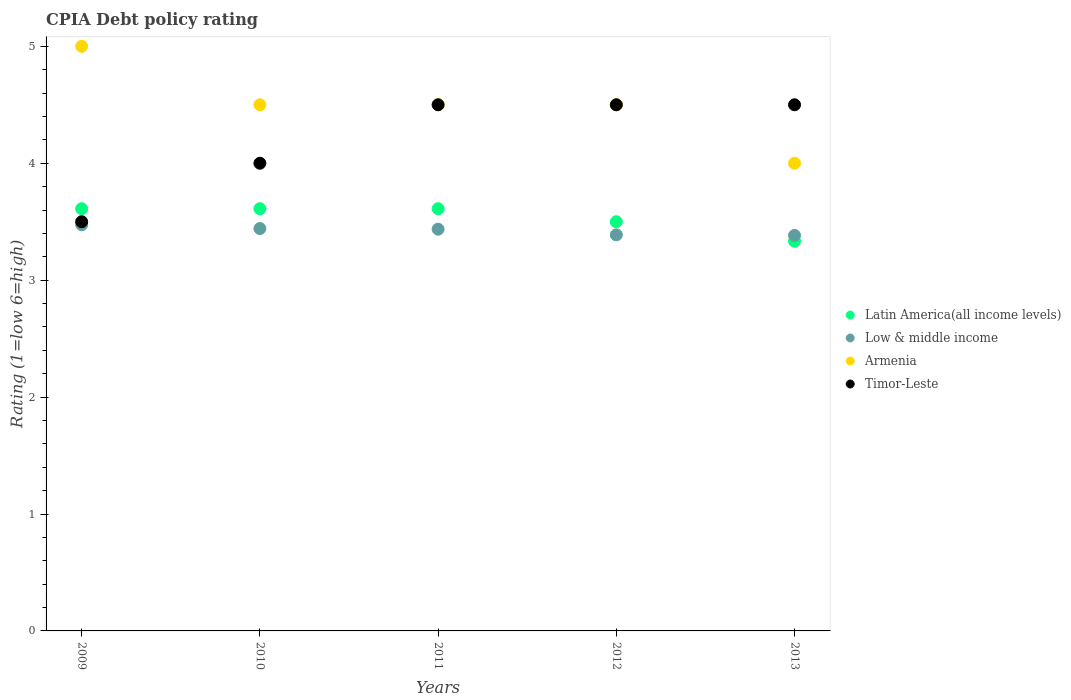How many different coloured dotlines are there?
Provide a short and direct response. 4. Across all years, what is the maximum CPIA rating in Low & middle income?
Give a very brief answer. 3.47. Across all years, what is the minimum CPIA rating in Low & middle income?
Your answer should be compact. 3.38. What is the total CPIA rating in Low & middle income in the graph?
Keep it short and to the point. 17.12. What is the difference between the CPIA rating in Low & middle income in 2009 and that in 2012?
Your response must be concise. 0.09. What is the difference between the CPIA rating in Latin America(all income levels) in 2013 and the CPIA rating in Low & middle income in 2009?
Your answer should be very brief. -0.14. In the year 2012, what is the difference between the CPIA rating in Latin America(all income levels) and CPIA rating in Armenia?
Provide a short and direct response. -1. What is the ratio of the CPIA rating in Latin America(all income levels) in 2011 to that in 2013?
Offer a very short reply. 1.08. What is the difference between the highest and the second highest CPIA rating in Low & middle income?
Give a very brief answer. 0.03. In how many years, is the CPIA rating in Armenia greater than the average CPIA rating in Armenia taken over all years?
Keep it short and to the point. 1. Is it the case that in every year, the sum of the CPIA rating in Low & middle income and CPIA rating in Timor-Leste  is greater than the sum of CPIA rating in Latin America(all income levels) and CPIA rating in Armenia?
Provide a short and direct response. No. Is the CPIA rating in Low & middle income strictly greater than the CPIA rating in Latin America(all income levels) over the years?
Provide a succinct answer. No. How many dotlines are there?
Offer a very short reply. 4. What is the difference between two consecutive major ticks on the Y-axis?
Ensure brevity in your answer.  1. Are the values on the major ticks of Y-axis written in scientific E-notation?
Provide a succinct answer. No. Does the graph contain grids?
Provide a short and direct response. No. What is the title of the graph?
Keep it short and to the point. CPIA Debt policy rating. Does "Croatia" appear as one of the legend labels in the graph?
Provide a succinct answer. No. What is the Rating (1=low 6=high) in Latin America(all income levels) in 2009?
Give a very brief answer. 3.61. What is the Rating (1=low 6=high) in Low & middle income in 2009?
Make the answer very short. 3.47. What is the Rating (1=low 6=high) of Timor-Leste in 2009?
Your answer should be very brief. 3.5. What is the Rating (1=low 6=high) in Latin America(all income levels) in 2010?
Offer a terse response. 3.61. What is the Rating (1=low 6=high) of Low & middle income in 2010?
Provide a succinct answer. 3.44. What is the Rating (1=low 6=high) of Armenia in 2010?
Offer a terse response. 4.5. What is the Rating (1=low 6=high) in Timor-Leste in 2010?
Your answer should be very brief. 4. What is the Rating (1=low 6=high) in Latin America(all income levels) in 2011?
Ensure brevity in your answer.  3.61. What is the Rating (1=low 6=high) in Low & middle income in 2011?
Keep it short and to the point. 3.44. What is the Rating (1=low 6=high) in Armenia in 2011?
Provide a succinct answer. 4.5. What is the Rating (1=low 6=high) of Timor-Leste in 2011?
Keep it short and to the point. 4.5. What is the Rating (1=low 6=high) of Low & middle income in 2012?
Offer a terse response. 3.39. What is the Rating (1=low 6=high) in Armenia in 2012?
Your answer should be very brief. 4.5. What is the Rating (1=low 6=high) of Latin America(all income levels) in 2013?
Your response must be concise. 3.33. What is the Rating (1=low 6=high) in Low & middle income in 2013?
Offer a very short reply. 3.38. What is the Rating (1=low 6=high) in Timor-Leste in 2013?
Make the answer very short. 4.5. Across all years, what is the maximum Rating (1=low 6=high) of Latin America(all income levels)?
Your answer should be very brief. 3.61. Across all years, what is the maximum Rating (1=low 6=high) in Low & middle income?
Give a very brief answer. 3.47. Across all years, what is the maximum Rating (1=low 6=high) in Armenia?
Provide a succinct answer. 5. Across all years, what is the minimum Rating (1=low 6=high) of Latin America(all income levels)?
Your answer should be very brief. 3.33. Across all years, what is the minimum Rating (1=low 6=high) of Low & middle income?
Offer a very short reply. 3.38. What is the total Rating (1=low 6=high) in Latin America(all income levels) in the graph?
Give a very brief answer. 17.67. What is the total Rating (1=low 6=high) of Low & middle income in the graph?
Your answer should be compact. 17.12. What is the total Rating (1=low 6=high) of Timor-Leste in the graph?
Your answer should be very brief. 21. What is the difference between the Rating (1=low 6=high) of Latin America(all income levels) in 2009 and that in 2010?
Your answer should be compact. 0. What is the difference between the Rating (1=low 6=high) in Low & middle income in 2009 and that in 2010?
Ensure brevity in your answer.  0.03. What is the difference between the Rating (1=low 6=high) in Armenia in 2009 and that in 2010?
Ensure brevity in your answer.  0.5. What is the difference between the Rating (1=low 6=high) of Low & middle income in 2009 and that in 2011?
Provide a succinct answer. 0.04. What is the difference between the Rating (1=low 6=high) of Armenia in 2009 and that in 2011?
Offer a terse response. 0.5. What is the difference between the Rating (1=low 6=high) in Timor-Leste in 2009 and that in 2011?
Keep it short and to the point. -1. What is the difference between the Rating (1=low 6=high) in Latin America(all income levels) in 2009 and that in 2012?
Provide a short and direct response. 0.11. What is the difference between the Rating (1=low 6=high) of Low & middle income in 2009 and that in 2012?
Keep it short and to the point. 0.09. What is the difference between the Rating (1=low 6=high) of Armenia in 2009 and that in 2012?
Keep it short and to the point. 0.5. What is the difference between the Rating (1=low 6=high) of Latin America(all income levels) in 2009 and that in 2013?
Your response must be concise. 0.28. What is the difference between the Rating (1=low 6=high) in Low & middle income in 2009 and that in 2013?
Keep it short and to the point. 0.09. What is the difference between the Rating (1=low 6=high) of Low & middle income in 2010 and that in 2011?
Your answer should be very brief. 0.01. What is the difference between the Rating (1=low 6=high) of Armenia in 2010 and that in 2011?
Offer a terse response. 0. What is the difference between the Rating (1=low 6=high) in Timor-Leste in 2010 and that in 2011?
Your answer should be very brief. -0.5. What is the difference between the Rating (1=low 6=high) in Latin America(all income levels) in 2010 and that in 2012?
Your answer should be compact. 0.11. What is the difference between the Rating (1=low 6=high) in Low & middle income in 2010 and that in 2012?
Offer a terse response. 0.05. What is the difference between the Rating (1=low 6=high) of Latin America(all income levels) in 2010 and that in 2013?
Your answer should be compact. 0.28. What is the difference between the Rating (1=low 6=high) in Low & middle income in 2010 and that in 2013?
Ensure brevity in your answer.  0.06. What is the difference between the Rating (1=low 6=high) in Latin America(all income levels) in 2011 and that in 2012?
Offer a terse response. 0.11. What is the difference between the Rating (1=low 6=high) of Low & middle income in 2011 and that in 2012?
Give a very brief answer. 0.05. What is the difference between the Rating (1=low 6=high) in Timor-Leste in 2011 and that in 2012?
Keep it short and to the point. 0. What is the difference between the Rating (1=low 6=high) of Latin America(all income levels) in 2011 and that in 2013?
Provide a succinct answer. 0.28. What is the difference between the Rating (1=low 6=high) of Low & middle income in 2011 and that in 2013?
Your answer should be compact. 0.05. What is the difference between the Rating (1=low 6=high) in Timor-Leste in 2011 and that in 2013?
Your response must be concise. 0. What is the difference between the Rating (1=low 6=high) of Latin America(all income levels) in 2012 and that in 2013?
Provide a succinct answer. 0.17. What is the difference between the Rating (1=low 6=high) of Low & middle income in 2012 and that in 2013?
Keep it short and to the point. 0. What is the difference between the Rating (1=low 6=high) in Timor-Leste in 2012 and that in 2013?
Your response must be concise. 0. What is the difference between the Rating (1=low 6=high) in Latin America(all income levels) in 2009 and the Rating (1=low 6=high) in Low & middle income in 2010?
Provide a succinct answer. 0.17. What is the difference between the Rating (1=low 6=high) of Latin America(all income levels) in 2009 and the Rating (1=low 6=high) of Armenia in 2010?
Offer a terse response. -0.89. What is the difference between the Rating (1=low 6=high) of Latin America(all income levels) in 2009 and the Rating (1=low 6=high) of Timor-Leste in 2010?
Make the answer very short. -0.39. What is the difference between the Rating (1=low 6=high) of Low & middle income in 2009 and the Rating (1=low 6=high) of Armenia in 2010?
Offer a terse response. -1.03. What is the difference between the Rating (1=low 6=high) of Low & middle income in 2009 and the Rating (1=low 6=high) of Timor-Leste in 2010?
Keep it short and to the point. -0.53. What is the difference between the Rating (1=low 6=high) in Latin America(all income levels) in 2009 and the Rating (1=low 6=high) in Low & middle income in 2011?
Make the answer very short. 0.18. What is the difference between the Rating (1=low 6=high) in Latin America(all income levels) in 2009 and the Rating (1=low 6=high) in Armenia in 2011?
Offer a very short reply. -0.89. What is the difference between the Rating (1=low 6=high) in Latin America(all income levels) in 2009 and the Rating (1=low 6=high) in Timor-Leste in 2011?
Keep it short and to the point. -0.89. What is the difference between the Rating (1=low 6=high) of Low & middle income in 2009 and the Rating (1=low 6=high) of Armenia in 2011?
Make the answer very short. -1.03. What is the difference between the Rating (1=low 6=high) in Low & middle income in 2009 and the Rating (1=low 6=high) in Timor-Leste in 2011?
Give a very brief answer. -1.03. What is the difference between the Rating (1=low 6=high) in Latin America(all income levels) in 2009 and the Rating (1=low 6=high) in Low & middle income in 2012?
Ensure brevity in your answer.  0.22. What is the difference between the Rating (1=low 6=high) in Latin America(all income levels) in 2009 and the Rating (1=low 6=high) in Armenia in 2012?
Ensure brevity in your answer.  -0.89. What is the difference between the Rating (1=low 6=high) of Latin America(all income levels) in 2009 and the Rating (1=low 6=high) of Timor-Leste in 2012?
Provide a short and direct response. -0.89. What is the difference between the Rating (1=low 6=high) of Low & middle income in 2009 and the Rating (1=low 6=high) of Armenia in 2012?
Your answer should be compact. -1.03. What is the difference between the Rating (1=low 6=high) in Low & middle income in 2009 and the Rating (1=low 6=high) in Timor-Leste in 2012?
Provide a short and direct response. -1.03. What is the difference between the Rating (1=low 6=high) in Armenia in 2009 and the Rating (1=low 6=high) in Timor-Leste in 2012?
Your response must be concise. 0.5. What is the difference between the Rating (1=low 6=high) in Latin America(all income levels) in 2009 and the Rating (1=low 6=high) in Low & middle income in 2013?
Provide a short and direct response. 0.23. What is the difference between the Rating (1=low 6=high) in Latin America(all income levels) in 2009 and the Rating (1=low 6=high) in Armenia in 2013?
Ensure brevity in your answer.  -0.39. What is the difference between the Rating (1=low 6=high) of Latin America(all income levels) in 2009 and the Rating (1=low 6=high) of Timor-Leste in 2013?
Offer a very short reply. -0.89. What is the difference between the Rating (1=low 6=high) of Low & middle income in 2009 and the Rating (1=low 6=high) of Armenia in 2013?
Provide a short and direct response. -0.53. What is the difference between the Rating (1=low 6=high) in Low & middle income in 2009 and the Rating (1=low 6=high) in Timor-Leste in 2013?
Make the answer very short. -1.03. What is the difference between the Rating (1=low 6=high) in Latin America(all income levels) in 2010 and the Rating (1=low 6=high) in Low & middle income in 2011?
Provide a succinct answer. 0.18. What is the difference between the Rating (1=low 6=high) in Latin America(all income levels) in 2010 and the Rating (1=low 6=high) in Armenia in 2011?
Keep it short and to the point. -0.89. What is the difference between the Rating (1=low 6=high) in Latin America(all income levels) in 2010 and the Rating (1=low 6=high) in Timor-Leste in 2011?
Your response must be concise. -0.89. What is the difference between the Rating (1=low 6=high) of Low & middle income in 2010 and the Rating (1=low 6=high) of Armenia in 2011?
Offer a terse response. -1.06. What is the difference between the Rating (1=low 6=high) of Low & middle income in 2010 and the Rating (1=low 6=high) of Timor-Leste in 2011?
Your answer should be compact. -1.06. What is the difference between the Rating (1=low 6=high) in Armenia in 2010 and the Rating (1=low 6=high) in Timor-Leste in 2011?
Ensure brevity in your answer.  0. What is the difference between the Rating (1=low 6=high) of Latin America(all income levels) in 2010 and the Rating (1=low 6=high) of Low & middle income in 2012?
Your answer should be compact. 0.22. What is the difference between the Rating (1=low 6=high) in Latin America(all income levels) in 2010 and the Rating (1=low 6=high) in Armenia in 2012?
Give a very brief answer. -0.89. What is the difference between the Rating (1=low 6=high) in Latin America(all income levels) in 2010 and the Rating (1=low 6=high) in Timor-Leste in 2012?
Ensure brevity in your answer.  -0.89. What is the difference between the Rating (1=low 6=high) in Low & middle income in 2010 and the Rating (1=low 6=high) in Armenia in 2012?
Offer a very short reply. -1.06. What is the difference between the Rating (1=low 6=high) in Low & middle income in 2010 and the Rating (1=low 6=high) in Timor-Leste in 2012?
Make the answer very short. -1.06. What is the difference between the Rating (1=low 6=high) in Latin America(all income levels) in 2010 and the Rating (1=low 6=high) in Low & middle income in 2013?
Make the answer very short. 0.23. What is the difference between the Rating (1=low 6=high) of Latin America(all income levels) in 2010 and the Rating (1=low 6=high) of Armenia in 2013?
Make the answer very short. -0.39. What is the difference between the Rating (1=low 6=high) in Latin America(all income levels) in 2010 and the Rating (1=low 6=high) in Timor-Leste in 2013?
Give a very brief answer. -0.89. What is the difference between the Rating (1=low 6=high) of Low & middle income in 2010 and the Rating (1=low 6=high) of Armenia in 2013?
Provide a short and direct response. -0.56. What is the difference between the Rating (1=low 6=high) in Low & middle income in 2010 and the Rating (1=low 6=high) in Timor-Leste in 2013?
Provide a succinct answer. -1.06. What is the difference between the Rating (1=low 6=high) of Latin America(all income levels) in 2011 and the Rating (1=low 6=high) of Low & middle income in 2012?
Offer a very short reply. 0.22. What is the difference between the Rating (1=low 6=high) of Latin America(all income levels) in 2011 and the Rating (1=low 6=high) of Armenia in 2012?
Provide a succinct answer. -0.89. What is the difference between the Rating (1=low 6=high) in Latin America(all income levels) in 2011 and the Rating (1=low 6=high) in Timor-Leste in 2012?
Ensure brevity in your answer.  -0.89. What is the difference between the Rating (1=low 6=high) in Low & middle income in 2011 and the Rating (1=low 6=high) in Armenia in 2012?
Provide a succinct answer. -1.06. What is the difference between the Rating (1=low 6=high) of Low & middle income in 2011 and the Rating (1=low 6=high) of Timor-Leste in 2012?
Provide a short and direct response. -1.06. What is the difference between the Rating (1=low 6=high) in Latin America(all income levels) in 2011 and the Rating (1=low 6=high) in Low & middle income in 2013?
Offer a terse response. 0.23. What is the difference between the Rating (1=low 6=high) in Latin America(all income levels) in 2011 and the Rating (1=low 6=high) in Armenia in 2013?
Keep it short and to the point. -0.39. What is the difference between the Rating (1=low 6=high) in Latin America(all income levels) in 2011 and the Rating (1=low 6=high) in Timor-Leste in 2013?
Your response must be concise. -0.89. What is the difference between the Rating (1=low 6=high) in Low & middle income in 2011 and the Rating (1=low 6=high) in Armenia in 2013?
Provide a short and direct response. -0.56. What is the difference between the Rating (1=low 6=high) in Low & middle income in 2011 and the Rating (1=low 6=high) in Timor-Leste in 2013?
Keep it short and to the point. -1.06. What is the difference between the Rating (1=low 6=high) of Armenia in 2011 and the Rating (1=low 6=high) of Timor-Leste in 2013?
Offer a terse response. 0. What is the difference between the Rating (1=low 6=high) in Latin America(all income levels) in 2012 and the Rating (1=low 6=high) in Low & middle income in 2013?
Make the answer very short. 0.12. What is the difference between the Rating (1=low 6=high) in Latin America(all income levels) in 2012 and the Rating (1=low 6=high) in Timor-Leste in 2013?
Ensure brevity in your answer.  -1. What is the difference between the Rating (1=low 6=high) of Low & middle income in 2012 and the Rating (1=low 6=high) of Armenia in 2013?
Offer a terse response. -0.61. What is the difference between the Rating (1=low 6=high) of Low & middle income in 2012 and the Rating (1=low 6=high) of Timor-Leste in 2013?
Provide a succinct answer. -1.11. What is the difference between the Rating (1=low 6=high) of Armenia in 2012 and the Rating (1=low 6=high) of Timor-Leste in 2013?
Keep it short and to the point. 0. What is the average Rating (1=low 6=high) of Latin America(all income levels) per year?
Your answer should be very brief. 3.53. What is the average Rating (1=low 6=high) of Low & middle income per year?
Offer a terse response. 3.42. What is the average Rating (1=low 6=high) in Armenia per year?
Provide a succinct answer. 4.5. In the year 2009, what is the difference between the Rating (1=low 6=high) of Latin America(all income levels) and Rating (1=low 6=high) of Low & middle income?
Make the answer very short. 0.14. In the year 2009, what is the difference between the Rating (1=low 6=high) of Latin America(all income levels) and Rating (1=low 6=high) of Armenia?
Make the answer very short. -1.39. In the year 2009, what is the difference between the Rating (1=low 6=high) of Low & middle income and Rating (1=low 6=high) of Armenia?
Keep it short and to the point. -1.53. In the year 2009, what is the difference between the Rating (1=low 6=high) in Low & middle income and Rating (1=low 6=high) in Timor-Leste?
Offer a terse response. -0.03. In the year 2009, what is the difference between the Rating (1=low 6=high) in Armenia and Rating (1=low 6=high) in Timor-Leste?
Provide a succinct answer. 1.5. In the year 2010, what is the difference between the Rating (1=low 6=high) in Latin America(all income levels) and Rating (1=low 6=high) in Low & middle income?
Provide a succinct answer. 0.17. In the year 2010, what is the difference between the Rating (1=low 6=high) of Latin America(all income levels) and Rating (1=low 6=high) of Armenia?
Make the answer very short. -0.89. In the year 2010, what is the difference between the Rating (1=low 6=high) in Latin America(all income levels) and Rating (1=low 6=high) in Timor-Leste?
Your answer should be compact. -0.39. In the year 2010, what is the difference between the Rating (1=low 6=high) of Low & middle income and Rating (1=low 6=high) of Armenia?
Provide a short and direct response. -1.06. In the year 2010, what is the difference between the Rating (1=low 6=high) in Low & middle income and Rating (1=low 6=high) in Timor-Leste?
Give a very brief answer. -0.56. In the year 2010, what is the difference between the Rating (1=low 6=high) in Armenia and Rating (1=low 6=high) in Timor-Leste?
Keep it short and to the point. 0.5. In the year 2011, what is the difference between the Rating (1=low 6=high) of Latin America(all income levels) and Rating (1=low 6=high) of Low & middle income?
Make the answer very short. 0.18. In the year 2011, what is the difference between the Rating (1=low 6=high) of Latin America(all income levels) and Rating (1=low 6=high) of Armenia?
Offer a very short reply. -0.89. In the year 2011, what is the difference between the Rating (1=low 6=high) of Latin America(all income levels) and Rating (1=low 6=high) of Timor-Leste?
Provide a succinct answer. -0.89. In the year 2011, what is the difference between the Rating (1=low 6=high) in Low & middle income and Rating (1=low 6=high) in Armenia?
Make the answer very short. -1.06. In the year 2011, what is the difference between the Rating (1=low 6=high) in Low & middle income and Rating (1=low 6=high) in Timor-Leste?
Ensure brevity in your answer.  -1.06. In the year 2011, what is the difference between the Rating (1=low 6=high) in Armenia and Rating (1=low 6=high) in Timor-Leste?
Offer a very short reply. 0. In the year 2012, what is the difference between the Rating (1=low 6=high) in Latin America(all income levels) and Rating (1=low 6=high) in Low & middle income?
Your response must be concise. 0.11. In the year 2012, what is the difference between the Rating (1=low 6=high) of Latin America(all income levels) and Rating (1=low 6=high) of Armenia?
Make the answer very short. -1. In the year 2012, what is the difference between the Rating (1=low 6=high) of Latin America(all income levels) and Rating (1=low 6=high) of Timor-Leste?
Your response must be concise. -1. In the year 2012, what is the difference between the Rating (1=low 6=high) in Low & middle income and Rating (1=low 6=high) in Armenia?
Make the answer very short. -1.11. In the year 2012, what is the difference between the Rating (1=low 6=high) in Low & middle income and Rating (1=low 6=high) in Timor-Leste?
Give a very brief answer. -1.11. In the year 2013, what is the difference between the Rating (1=low 6=high) of Latin America(all income levels) and Rating (1=low 6=high) of Low & middle income?
Provide a succinct answer. -0.05. In the year 2013, what is the difference between the Rating (1=low 6=high) of Latin America(all income levels) and Rating (1=low 6=high) of Armenia?
Give a very brief answer. -0.67. In the year 2013, what is the difference between the Rating (1=low 6=high) of Latin America(all income levels) and Rating (1=low 6=high) of Timor-Leste?
Keep it short and to the point. -1.17. In the year 2013, what is the difference between the Rating (1=low 6=high) of Low & middle income and Rating (1=low 6=high) of Armenia?
Ensure brevity in your answer.  -0.62. In the year 2013, what is the difference between the Rating (1=low 6=high) of Low & middle income and Rating (1=low 6=high) of Timor-Leste?
Offer a very short reply. -1.12. In the year 2013, what is the difference between the Rating (1=low 6=high) in Armenia and Rating (1=low 6=high) in Timor-Leste?
Your answer should be compact. -0.5. What is the ratio of the Rating (1=low 6=high) in Latin America(all income levels) in 2009 to that in 2010?
Give a very brief answer. 1. What is the ratio of the Rating (1=low 6=high) of Low & middle income in 2009 to that in 2010?
Offer a very short reply. 1.01. What is the ratio of the Rating (1=low 6=high) in Timor-Leste in 2009 to that in 2010?
Your answer should be compact. 0.88. What is the ratio of the Rating (1=low 6=high) of Latin America(all income levels) in 2009 to that in 2011?
Offer a terse response. 1. What is the ratio of the Rating (1=low 6=high) in Low & middle income in 2009 to that in 2011?
Ensure brevity in your answer.  1.01. What is the ratio of the Rating (1=low 6=high) of Armenia in 2009 to that in 2011?
Give a very brief answer. 1.11. What is the ratio of the Rating (1=low 6=high) in Timor-Leste in 2009 to that in 2011?
Your response must be concise. 0.78. What is the ratio of the Rating (1=low 6=high) in Latin America(all income levels) in 2009 to that in 2012?
Offer a terse response. 1.03. What is the ratio of the Rating (1=low 6=high) in Low & middle income in 2009 to that in 2012?
Offer a very short reply. 1.03. What is the ratio of the Rating (1=low 6=high) of Timor-Leste in 2009 to that in 2012?
Your answer should be compact. 0.78. What is the ratio of the Rating (1=low 6=high) in Latin America(all income levels) in 2010 to that in 2011?
Provide a short and direct response. 1. What is the ratio of the Rating (1=low 6=high) in Timor-Leste in 2010 to that in 2011?
Provide a short and direct response. 0.89. What is the ratio of the Rating (1=low 6=high) of Latin America(all income levels) in 2010 to that in 2012?
Make the answer very short. 1.03. What is the ratio of the Rating (1=low 6=high) of Low & middle income in 2010 to that in 2012?
Provide a short and direct response. 1.02. What is the ratio of the Rating (1=low 6=high) in Armenia in 2010 to that in 2012?
Your answer should be very brief. 1. What is the ratio of the Rating (1=low 6=high) of Timor-Leste in 2010 to that in 2012?
Your answer should be very brief. 0.89. What is the ratio of the Rating (1=low 6=high) in Low & middle income in 2010 to that in 2013?
Offer a very short reply. 1.02. What is the ratio of the Rating (1=low 6=high) in Latin America(all income levels) in 2011 to that in 2012?
Make the answer very short. 1.03. What is the ratio of the Rating (1=low 6=high) of Low & middle income in 2011 to that in 2012?
Provide a succinct answer. 1.01. What is the ratio of the Rating (1=low 6=high) of Armenia in 2011 to that in 2012?
Offer a very short reply. 1. What is the ratio of the Rating (1=low 6=high) in Timor-Leste in 2011 to that in 2012?
Your response must be concise. 1. What is the ratio of the Rating (1=low 6=high) in Latin America(all income levels) in 2011 to that in 2013?
Your answer should be very brief. 1.08. What is the ratio of the Rating (1=low 6=high) in Low & middle income in 2011 to that in 2013?
Your response must be concise. 1.02. What is the ratio of the Rating (1=low 6=high) in Armenia in 2011 to that in 2013?
Keep it short and to the point. 1.12. What is the ratio of the Rating (1=low 6=high) of Timor-Leste in 2011 to that in 2013?
Provide a short and direct response. 1. What is the ratio of the Rating (1=low 6=high) of Timor-Leste in 2012 to that in 2013?
Provide a succinct answer. 1. What is the difference between the highest and the second highest Rating (1=low 6=high) in Low & middle income?
Give a very brief answer. 0.03. What is the difference between the highest and the second highest Rating (1=low 6=high) of Armenia?
Provide a short and direct response. 0.5. What is the difference between the highest and the lowest Rating (1=low 6=high) of Latin America(all income levels)?
Provide a succinct answer. 0.28. What is the difference between the highest and the lowest Rating (1=low 6=high) of Low & middle income?
Provide a succinct answer. 0.09. What is the difference between the highest and the lowest Rating (1=low 6=high) of Armenia?
Give a very brief answer. 1. 